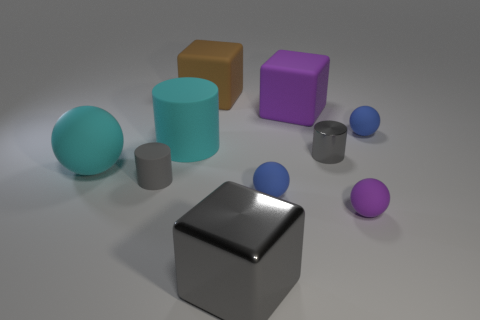What is the color of the large matte thing that is the same shape as the small gray metallic object?
Offer a terse response. Cyan. Are there any yellow shiny objects that have the same shape as the large brown rubber thing?
Provide a short and direct response. No. What is the shape of the tiny purple matte object?
Your answer should be very brief. Sphere. The small gray thing on the left side of the big gray block that is in front of the large cyan thing in front of the gray metallic cylinder is made of what material?
Offer a terse response. Rubber. Are there more matte cylinders that are behind the gray matte thing than brown balls?
Your response must be concise. Yes. There is a brown object that is the same size as the gray metallic block; what is its material?
Keep it short and to the point. Rubber. Is there a yellow rubber cube that has the same size as the gray shiny cube?
Keep it short and to the point. No. There is a object that is to the left of the gray rubber cylinder; what size is it?
Provide a short and direct response. Large. What is the size of the shiny cube?
Ensure brevity in your answer.  Large. What number of balls are tiny red objects or small gray objects?
Give a very brief answer. 0. 